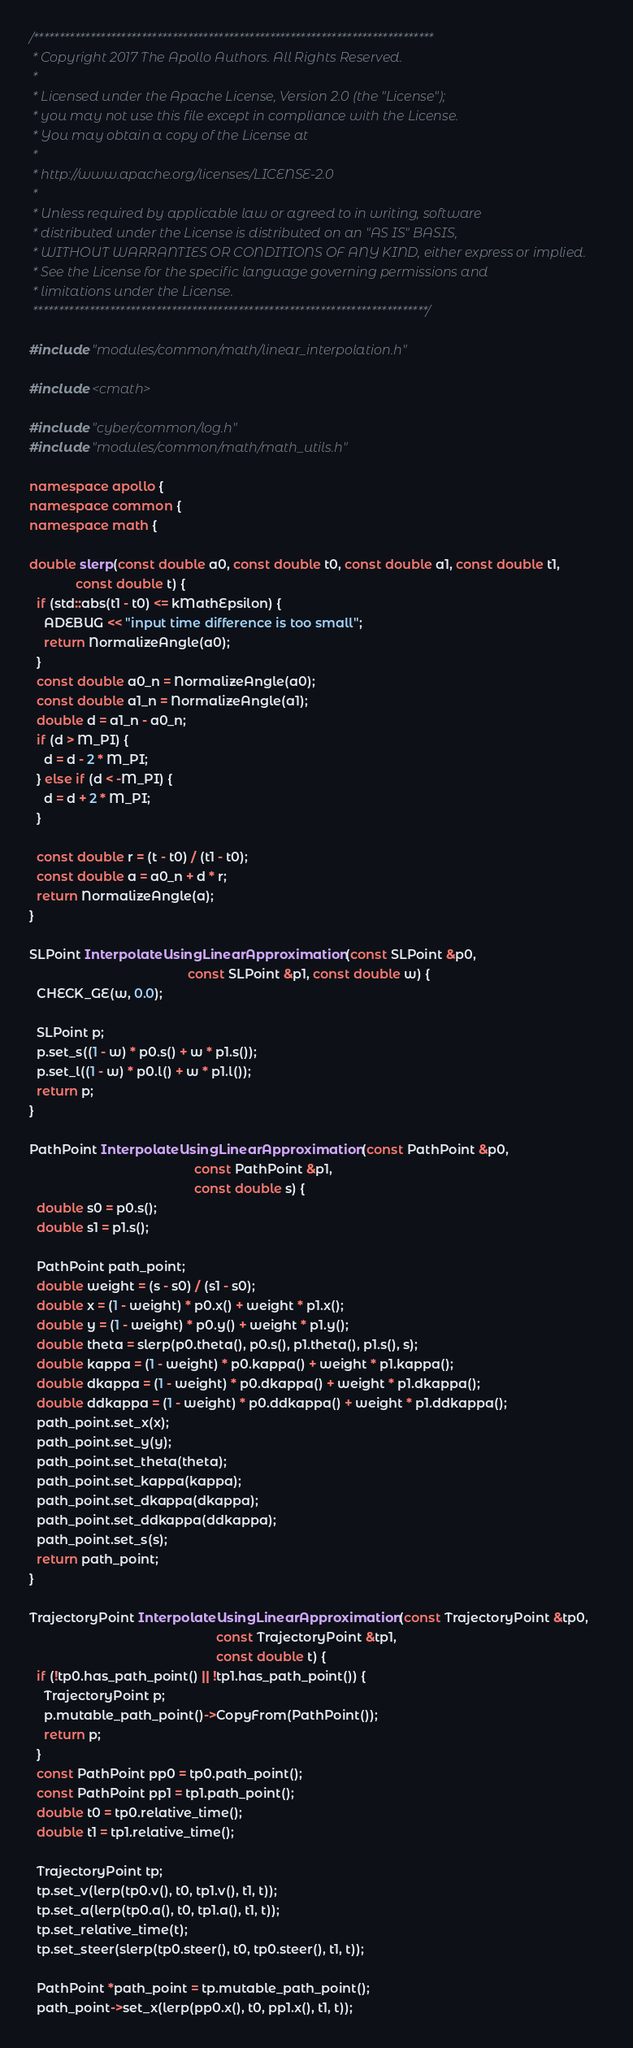Convert code to text. <code><loc_0><loc_0><loc_500><loc_500><_C++_>/******************************************************************************
 * Copyright 2017 The Apollo Authors. All Rights Reserved.
 *
 * Licensed under the Apache License, Version 2.0 (the "License");
 * you may not use this file except in compliance with the License.
 * You may obtain a copy of the License at
 *
 * http://www.apache.org/licenses/LICENSE-2.0
 *
 * Unless required by applicable law or agreed to in writing, software
 * distributed under the License is distributed on an "AS IS" BASIS,
 * WITHOUT WARRANTIES OR CONDITIONS OF ANY KIND, either express or implied.
 * See the License for the specific language governing permissions and
 * limitations under the License.
 *****************************************************************************/

#include "modules/common/math/linear_interpolation.h"

#include <cmath>

#include "cyber/common/log.h"
#include "modules/common/math/math_utils.h"

namespace apollo {
namespace common {
namespace math {

double slerp(const double a0, const double t0, const double a1, const double t1,
             const double t) {
  if (std::abs(t1 - t0) <= kMathEpsilon) {
    ADEBUG << "input time difference is too small";
    return NormalizeAngle(a0);
  }
  const double a0_n = NormalizeAngle(a0);
  const double a1_n = NormalizeAngle(a1);
  double d = a1_n - a0_n;
  if (d > M_PI) {
    d = d - 2 * M_PI;
  } else if (d < -M_PI) {
    d = d + 2 * M_PI;
  }

  const double r = (t - t0) / (t1 - t0);
  const double a = a0_n + d * r;
  return NormalizeAngle(a);
}

SLPoint InterpolateUsingLinearApproximation(const SLPoint &p0,
                                            const SLPoint &p1, const double w) {
  CHECK_GE(w, 0.0);

  SLPoint p;
  p.set_s((1 - w) * p0.s() + w * p1.s());
  p.set_l((1 - w) * p0.l() + w * p1.l());
  return p;
}

PathPoint InterpolateUsingLinearApproximation(const PathPoint &p0,
                                              const PathPoint &p1,
                                              const double s) {
  double s0 = p0.s();
  double s1 = p1.s();

  PathPoint path_point;
  double weight = (s - s0) / (s1 - s0);
  double x = (1 - weight) * p0.x() + weight * p1.x();
  double y = (1 - weight) * p0.y() + weight * p1.y();
  double theta = slerp(p0.theta(), p0.s(), p1.theta(), p1.s(), s);
  double kappa = (1 - weight) * p0.kappa() + weight * p1.kappa();
  double dkappa = (1 - weight) * p0.dkappa() + weight * p1.dkappa();
  double ddkappa = (1 - weight) * p0.ddkappa() + weight * p1.ddkappa();
  path_point.set_x(x);
  path_point.set_y(y);
  path_point.set_theta(theta);
  path_point.set_kappa(kappa);
  path_point.set_dkappa(dkappa);
  path_point.set_ddkappa(ddkappa);
  path_point.set_s(s);
  return path_point;
}

TrajectoryPoint InterpolateUsingLinearApproximation(const TrajectoryPoint &tp0,
                                                    const TrajectoryPoint &tp1,
                                                    const double t) {
  if (!tp0.has_path_point() || !tp1.has_path_point()) {
    TrajectoryPoint p;
    p.mutable_path_point()->CopyFrom(PathPoint());
    return p;
  }
  const PathPoint pp0 = tp0.path_point();
  const PathPoint pp1 = tp1.path_point();
  double t0 = tp0.relative_time();
  double t1 = tp1.relative_time();

  TrajectoryPoint tp;
  tp.set_v(lerp(tp0.v(), t0, tp1.v(), t1, t));
  tp.set_a(lerp(tp0.a(), t0, tp1.a(), t1, t));
  tp.set_relative_time(t);
  tp.set_steer(slerp(tp0.steer(), t0, tp0.steer(), t1, t));

  PathPoint *path_point = tp.mutable_path_point();
  path_point->set_x(lerp(pp0.x(), t0, pp1.x(), t1, t));</code> 